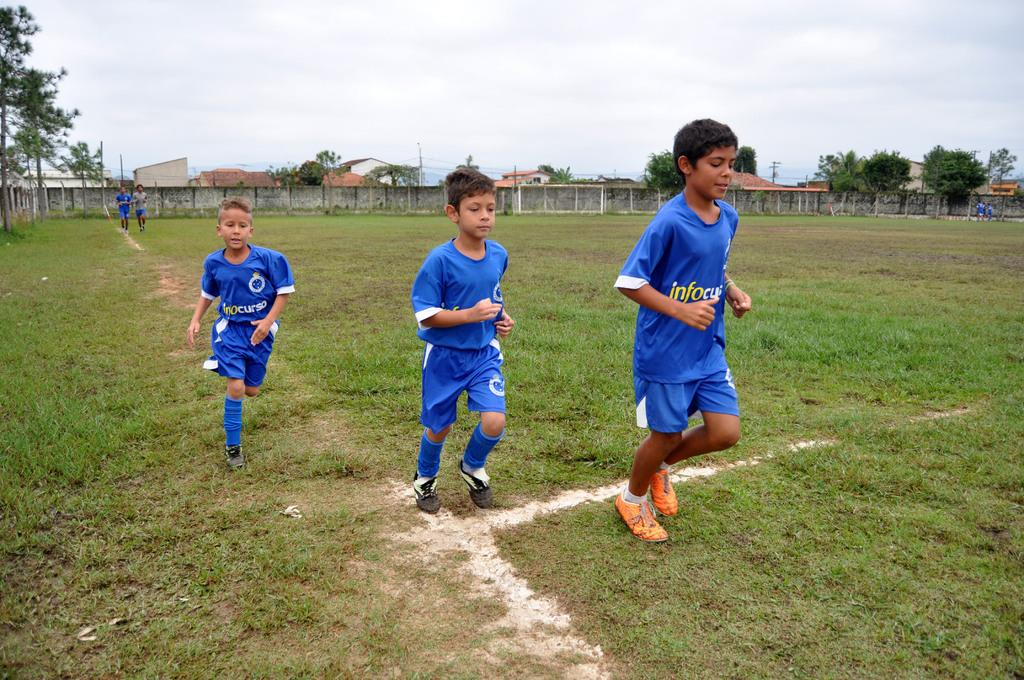What are the kids doing in the image? The kids are standing on the ground in the image. What type of surface are the kids standing on? There is grass on the ground where the kids are standing. What can be seen in the background of the image? There are buildings and trees in the background. How would you describe the weather based on the image? The sky is cloudy in the image. Who is the owner of the plane in the image? There is no plane present in the image, so there is no owner to identify. How does the person in the image control the trees in the background? There is no person in the image controlling the trees; they are simply part of the background. 